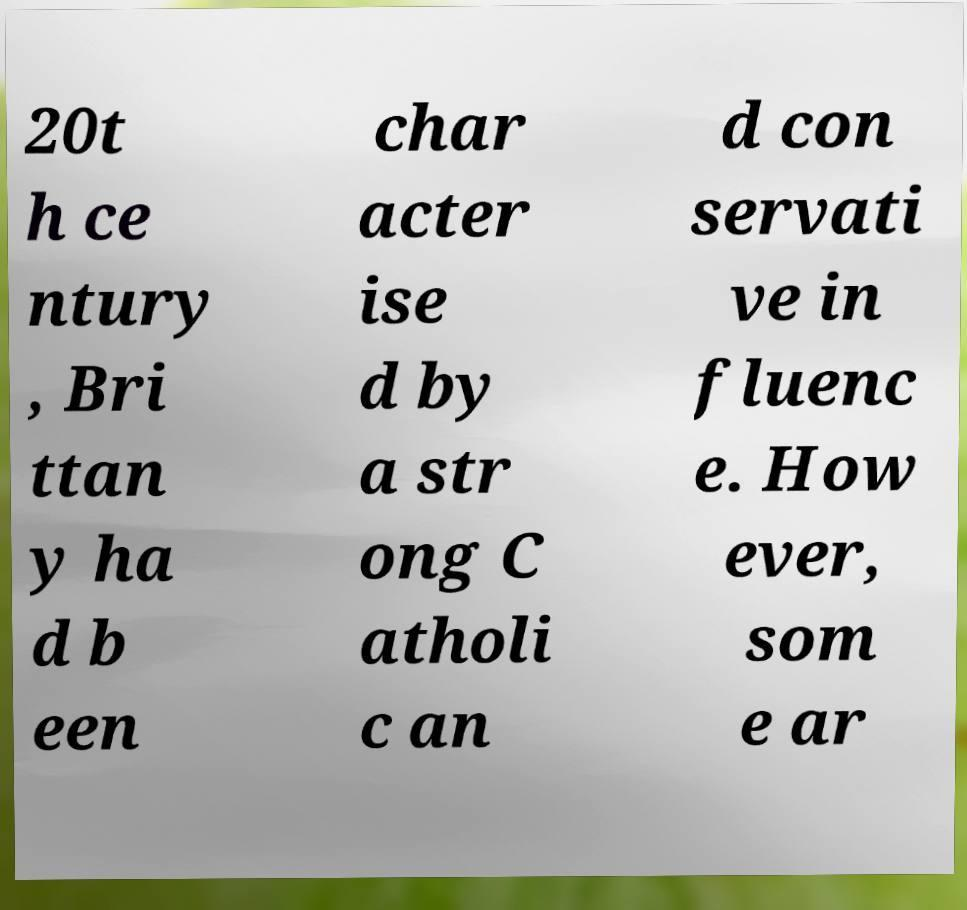I need the written content from this picture converted into text. Can you do that? 20t h ce ntury , Bri ttan y ha d b een char acter ise d by a str ong C atholi c an d con servati ve in fluenc e. How ever, som e ar 